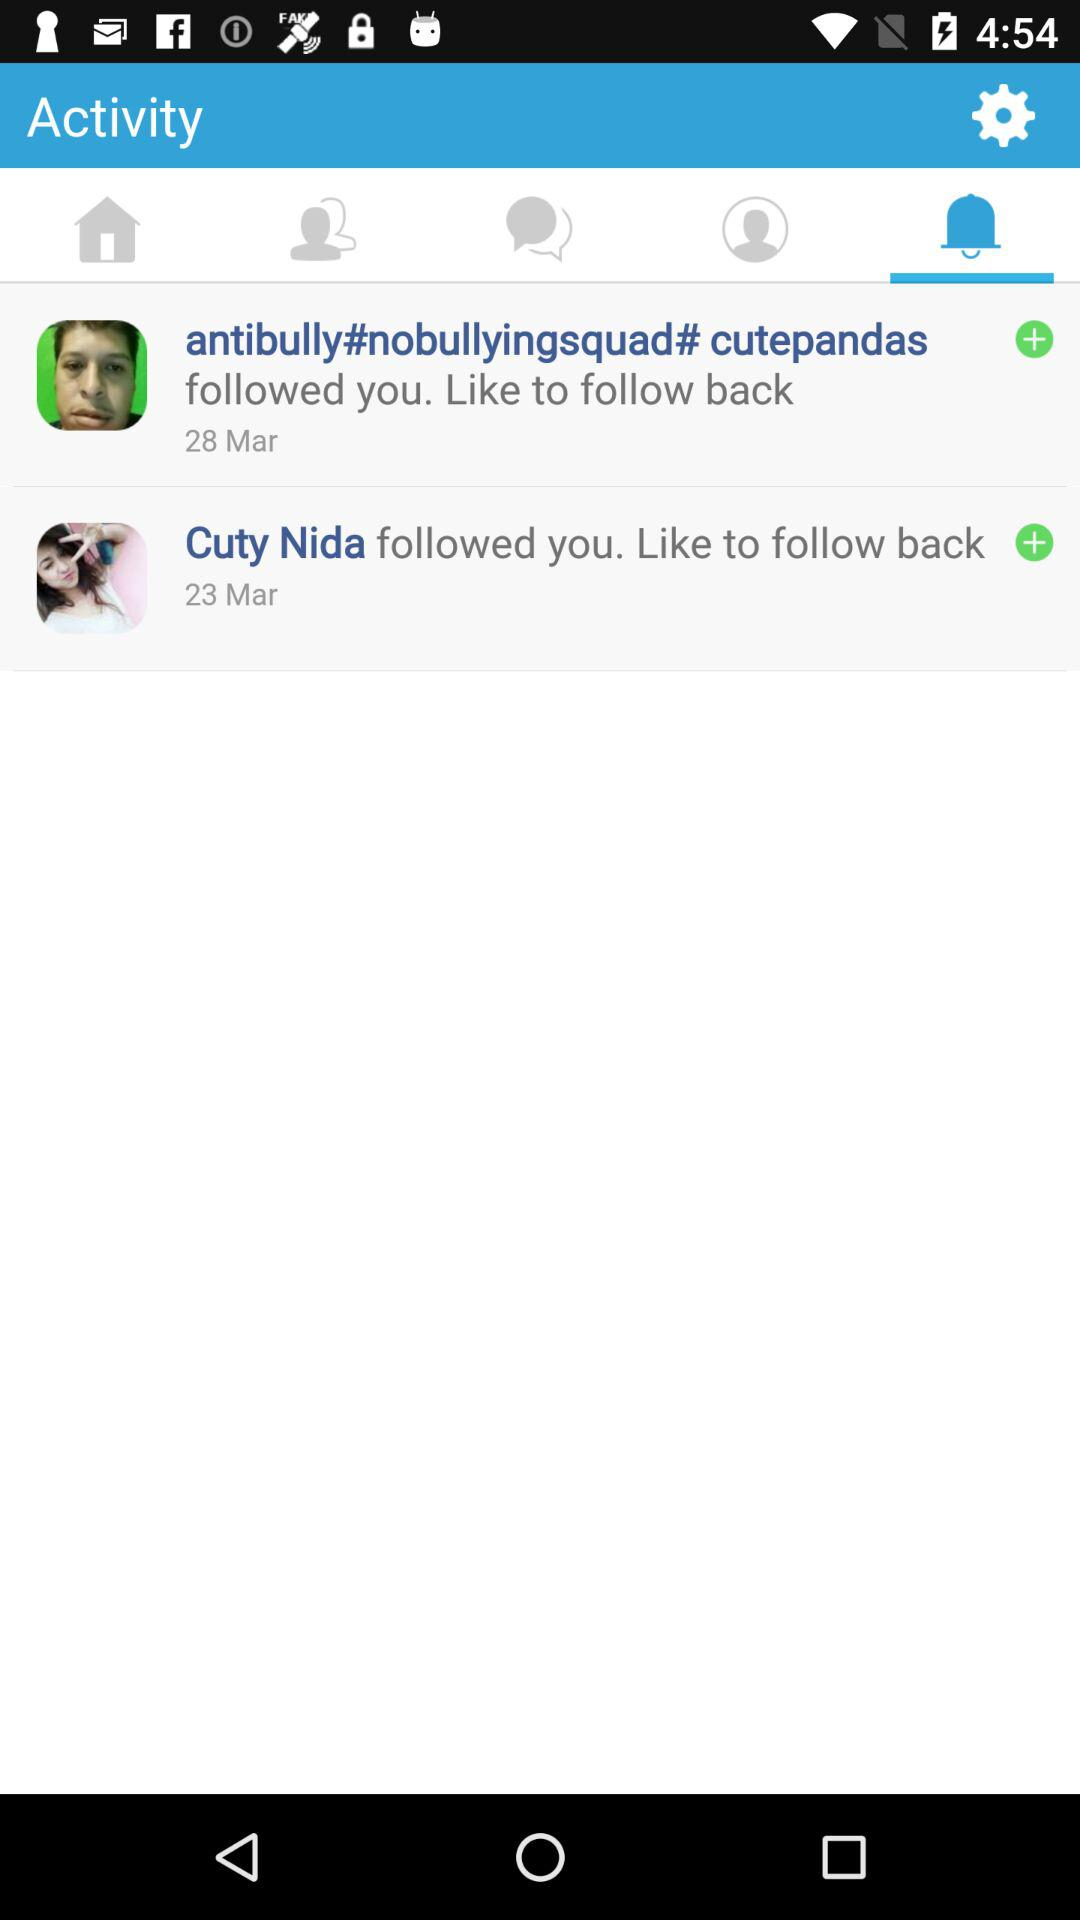Which tab is selected? The selected tab is "Notifications". 